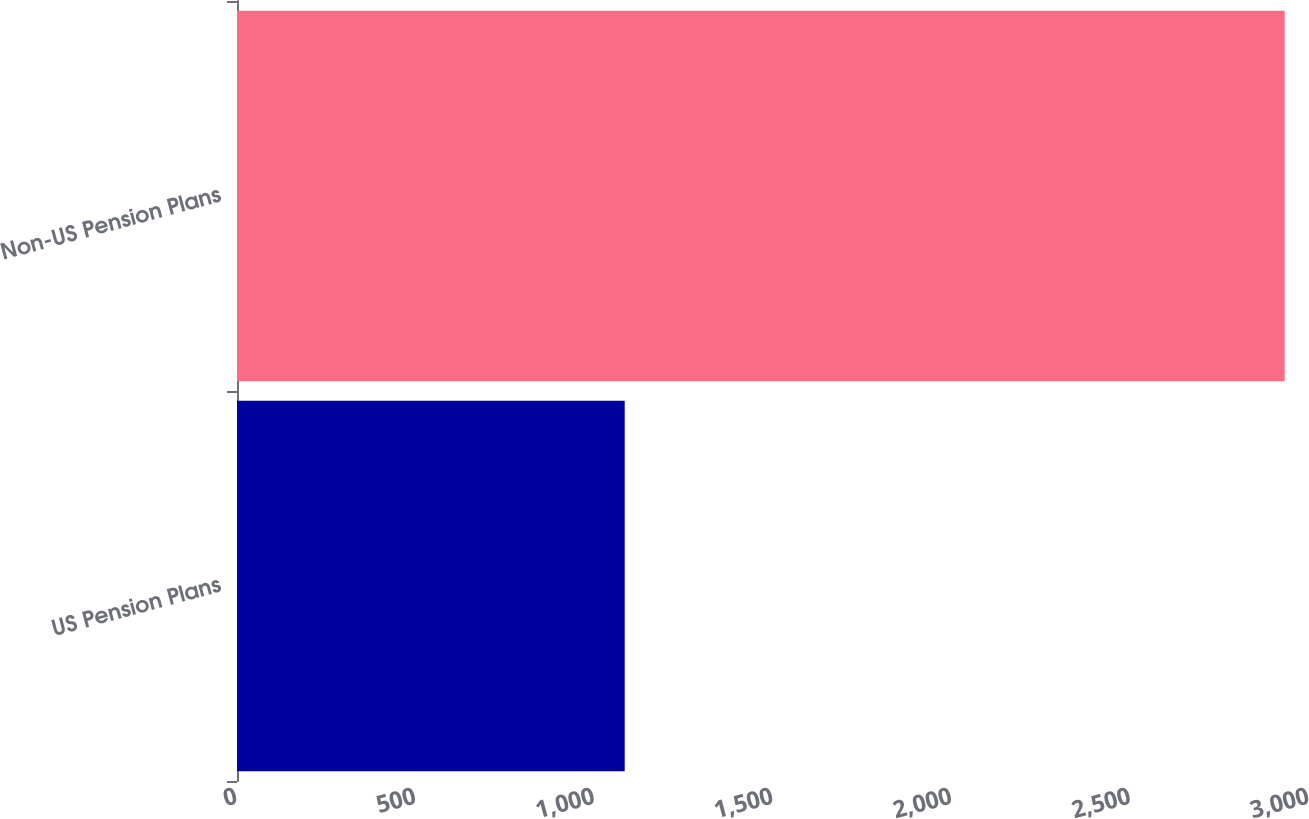Convert chart to OTSL. <chart><loc_0><loc_0><loc_500><loc_500><bar_chart><fcel>US Pension Plans<fcel>Non-US Pension Plans<nl><fcel>1085<fcel>2932<nl></chart> 